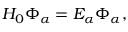<formula> <loc_0><loc_0><loc_500><loc_500>H _ { 0 } \Phi _ { \alpha } = E _ { \alpha } \Phi _ { \alpha } ,</formula> 